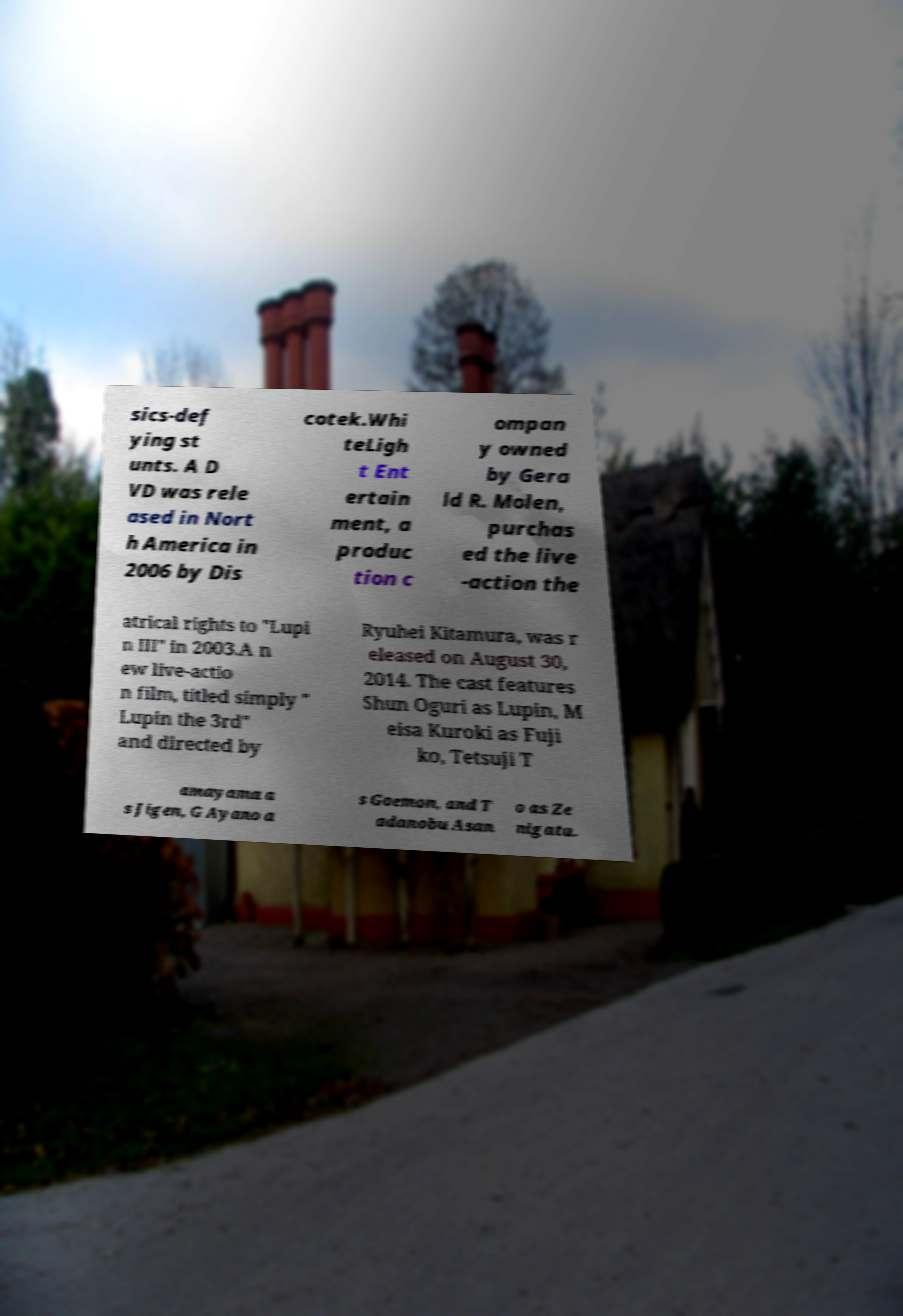Please identify and transcribe the text found in this image. sics-def ying st unts. A D VD was rele ased in Nort h America in 2006 by Dis cotek.Whi teLigh t Ent ertain ment, a produc tion c ompan y owned by Gera ld R. Molen, purchas ed the live -action the atrical rights to "Lupi n III" in 2003.A n ew live-actio n film, titled simply " Lupin the 3rd" and directed by Ryuhei Kitamura, was r eleased on August 30, 2014. The cast features Shun Oguri as Lupin, M eisa Kuroki as Fuji ko, Tetsuji T amayama a s Jigen, G Ayano a s Goemon, and T adanobu Asan o as Ze nigata. 